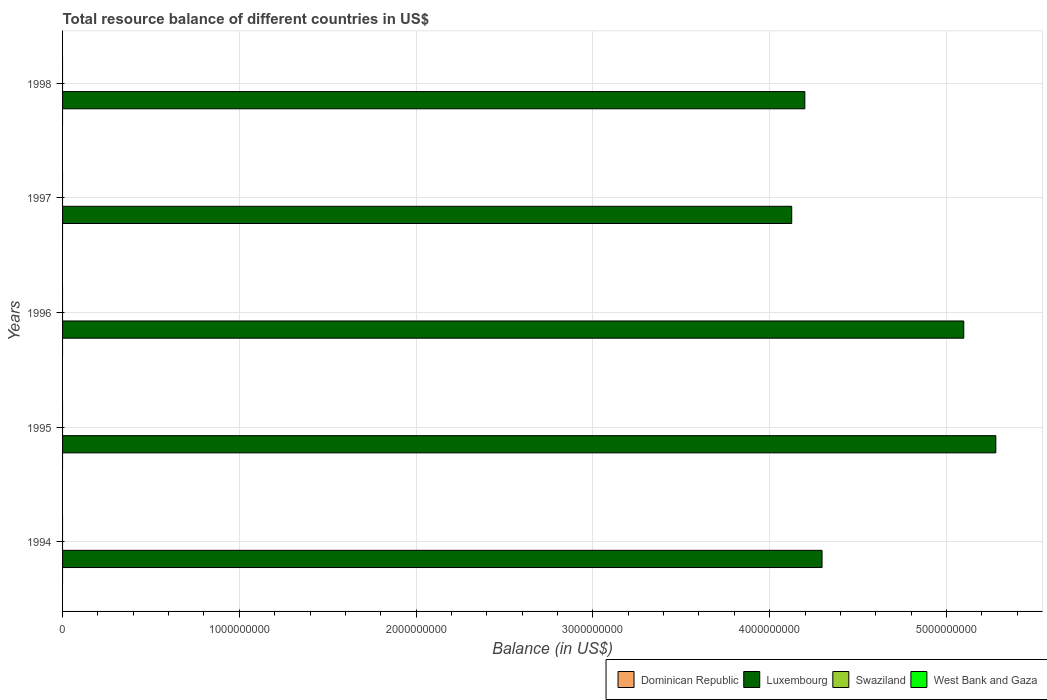Are the number of bars per tick equal to the number of legend labels?
Provide a short and direct response. No. In how many cases, is the number of bars for a given year not equal to the number of legend labels?
Provide a short and direct response. 5. What is the total resource balance in Dominican Republic in 1994?
Ensure brevity in your answer.  0. Across all years, what is the maximum total resource balance in Luxembourg?
Offer a terse response. 5.28e+09. Across all years, what is the minimum total resource balance in West Bank and Gaza?
Keep it short and to the point. 0. What is the total total resource balance in Luxembourg in the graph?
Offer a very short reply. 2.30e+1. What is the difference between the total resource balance in Luxembourg in 1994 and that in 1995?
Offer a very short reply. -9.83e+08. What is the average total resource balance in Dominican Republic per year?
Offer a very short reply. 0. In how many years, is the total resource balance in Luxembourg greater than 4200000000 US$?
Ensure brevity in your answer.  3. What is the ratio of the total resource balance in Luxembourg in 1995 to that in 1996?
Make the answer very short. 1.04. Is the total resource balance in Luxembourg in 1995 less than that in 1998?
Your answer should be very brief. No. What is the difference between the highest and the lowest total resource balance in Luxembourg?
Keep it short and to the point. 1.15e+09. Is it the case that in every year, the sum of the total resource balance in Dominican Republic and total resource balance in Swaziland is greater than the sum of total resource balance in Luxembourg and total resource balance in West Bank and Gaza?
Ensure brevity in your answer.  No. Is it the case that in every year, the sum of the total resource balance in Swaziland and total resource balance in Luxembourg is greater than the total resource balance in Dominican Republic?
Your answer should be compact. Yes. How many bars are there?
Ensure brevity in your answer.  5. What is the difference between two consecutive major ticks on the X-axis?
Provide a short and direct response. 1.00e+09. How are the legend labels stacked?
Offer a very short reply. Horizontal. What is the title of the graph?
Ensure brevity in your answer.  Total resource balance of different countries in US$. What is the label or title of the X-axis?
Keep it short and to the point. Balance (in US$). What is the Balance (in US$) of Dominican Republic in 1994?
Offer a terse response. 0. What is the Balance (in US$) in Luxembourg in 1994?
Offer a terse response. 4.30e+09. What is the Balance (in US$) of Swaziland in 1994?
Ensure brevity in your answer.  0. What is the Balance (in US$) of Dominican Republic in 1995?
Your answer should be very brief. 0. What is the Balance (in US$) in Luxembourg in 1995?
Offer a terse response. 5.28e+09. What is the Balance (in US$) in Swaziland in 1995?
Your response must be concise. 0. What is the Balance (in US$) in West Bank and Gaza in 1995?
Ensure brevity in your answer.  0. What is the Balance (in US$) in Luxembourg in 1996?
Provide a succinct answer. 5.10e+09. What is the Balance (in US$) in Dominican Republic in 1997?
Offer a terse response. 0. What is the Balance (in US$) of Luxembourg in 1997?
Ensure brevity in your answer.  4.12e+09. What is the Balance (in US$) of Dominican Republic in 1998?
Provide a succinct answer. 0. What is the Balance (in US$) in Luxembourg in 1998?
Make the answer very short. 4.20e+09. What is the Balance (in US$) in Swaziland in 1998?
Keep it short and to the point. 0. What is the Balance (in US$) in West Bank and Gaza in 1998?
Your answer should be very brief. 0. Across all years, what is the maximum Balance (in US$) in Luxembourg?
Your answer should be very brief. 5.28e+09. Across all years, what is the minimum Balance (in US$) of Luxembourg?
Give a very brief answer. 4.12e+09. What is the total Balance (in US$) of Dominican Republic in the graph?
Your response must be concise. 0. What is the total Balance (in US$) in Luxembourg in the graph?
Keep it short and to the point. 2.30e+1. What is the total Balance (in US$) of Swaziland in the graph?
Your answer should be very brief. 0. What is the difference between the Balance (in US$) in Luxembourg in 1994 and that in 1995?
Provide a short and direct response. -9.83e+08. What is the difference between the Balance (in US$) in Luxembourg in 1994 and that in 1996?
Offer a terse response. -8.02e+08. What is the difference between the Balance (in US$) in Luxembourg in 1994 and that in 1997?
Keep it short and to the point. 1.72e+08. What is the difference between the Balance (in US$) of Luxembourg in 1994 and that in 1998?
Keep it short and to the point. 9.74e+07. What is the difference between the Balance (in US$) in Luxembourg in 1995 and that in 1996?
Ensure brevity in your answer.  1.81e+08. What is the difference between the Balance (in US$) of Luxembourg in 1995 and that in 1997?
Offer a very short reply. 1.15e+09. What is the difference between the Balance (in US$) of Luxembourg in 1995 and that in 1998?
Ensure brevity in your answer.  1.08e+09. What is the difference between the Balance (in US$) in Luxembourg in 1996 and that in 1997?
Provide a short and direct response. 9.73e+08. What is the difference between the Balance (in US$) in Luxembourg in 1996 and that in 1998?
Give a very brief answer. 8.99e+08. What is the difference between the Balance (in US$) in Luxembourg in 1997 and that in 1998?
Make the answer very short. -7.42e+07. What is the average Balance (in US$) in Luxembourg per year?
Offer a terse response. 4.60e+09. What is the average Balance (in US$) of Swaziland per year?
Ensure brevity in your answer.  0. What is the ratio of the Balance (in US$) in Luxembourg in 1994 to that in 1995?
Give a very brief answer. 0.81. What is the ratio of the Balance (in US$) of Luxembourg in 1994 to that in 1996?
Provide a short and direct response. 0.84. What is the ratio of the Balance (in US$) of Luxembourg in 1994 to that in 1997?
Offer a terse response. 1.04. What is the ratio of the Balance (in US$) of Luxembourg in 1994 to that in 1998?
Ensure brevity in your answer.  1.02. What is the ratio of the Balance (in US$) in Luxembourg in 1995 to that in 1996?
Offer a very short reply. 1.04. What is the ratio of the Balance (in US$) of Luxembourg in 1995 to that in 1997?
Your response must be concise. 1.28. What is the ratio of the Balance (in US$) of Luxembourg in 1995 to that in 1998?
Your response must be concise. 1.26. What is the ratio of the Balance (in US$) in Luxembourg in 1996 to that in 1997?
Provide a short and direct response. 1.24. What is the ratio of the Balance (in US$) in Luxembourg in 1996 to that in 1998?
Provide a short and direct response. 1.21. What is the ratio of the Balance (in US$) in Luxembourg in 1997 to that in 1998?
Offer a terse response. 0.98. What is the difference between the highest and the second highest Balance (in US$) in Luxembourg?
Give a very brief answer. 1.81e+08. What is the difference between the highest and the lowest Balance (in US$) of Luxembourg?
Offer a terse response. 1.15e+09. 